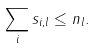<formula> <loc_0><loc_0><loc_500><loc_500>\sum _ { i } s _ { i , l } \leq n _ { l } .</formula> 